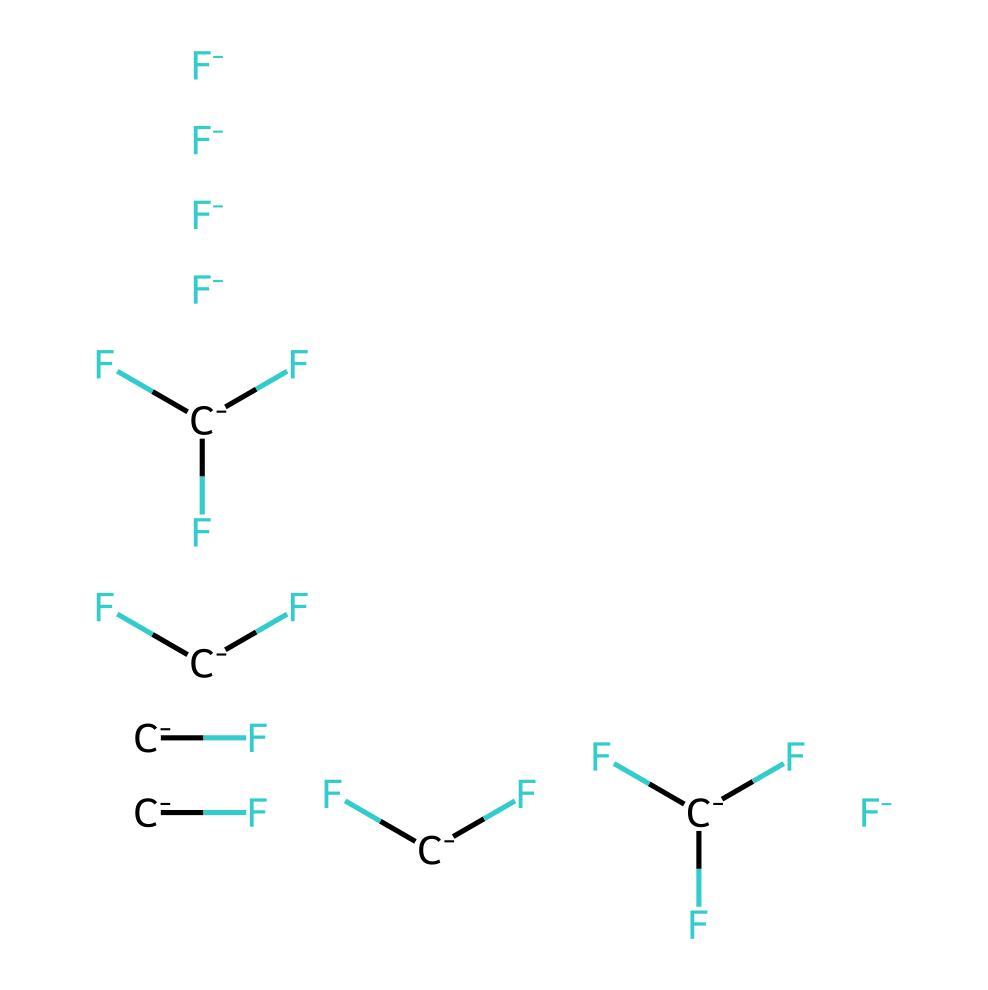What is the molecular formula of R-410A? The molecular structure represented in the SMILES includes various atoms, specifically fluorine (F) and carbon (C), which can be counted. There are 5 fluorine atoms and 6 carbon atoms in the structure, leading to the molecular formula of C5H2F12.
Answer: C5H2F12 How many carbon atoms are present in R-410A? By examining the SMILES representation, we can identify the carbon atoms present in the structure. There are 6 carbon atoms connected in various positions.
Answer: 6 What type of chemical is R-410A primarily used as? R-410A is recognized as a refrigerant, specifically a hydrofluorocarbon (HFC), which is evident from its use in modern HVAC systems as a cooling agent.
Answer: refrigerant How many hydrogen atoms are there in R-410A? Counting the hydrogen atoms in the given SMILES structure, we find that there are a total of 2 hydrogen atoms attached to the carbon backbone of the molecule.
Answer: 2 Which elements are dominant in the composition of R-410A? By analyzing the SMILES representation, it is clear that the elements present are mainly fluorine and carbon, with a smaller count of hydrogen, making fluorine the most dominant element in R-410A.
Answer: fluorine Is R-410A categorized as an environmentally friendly refrigerant? R-410A, while having low ozone depletion potential, does have a significant global warming potential, leading to ongoing discussions about its environmental impact, thus indicating that it isn't fully categorized as environmentally friendly.
Answer: no 